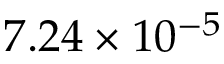Convert formula to latex. <formula><loc_0><loc_0><loc_500><loc_500>7 . 2 4 \times 1 0 ^ { - 5 }</formula> 